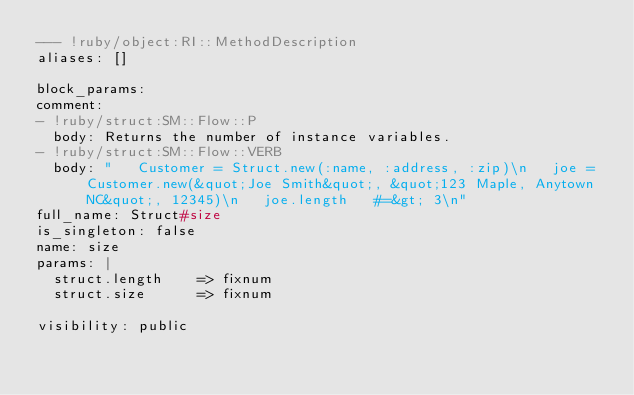<code> <loc_0><loc_0><loc_500><loc_500><_YAML_>--- !ruby/object:RI::MethodDescription 
aliases: []

block_params: 
comment: 
- !ruby/struct:SM::Flow::P 
  body: Returns the number of instance variables.
- !ruby/struct:SM::Flow::VERB 
  body: "   Customer = Struct.new(:name, :address, :zip)\n   joe = Customer.new(&quot;Joe Smith&quot;, &quot;123 Maple, Anytown NC&quot;, 12345)\n   joe.length   #=&gt; 3\n"
full_name: Struct#size
is_singleton: false
name: size
params: |
  struct.length    => fixnum
  struct.size      => fixnum

visibility: public
</code> 